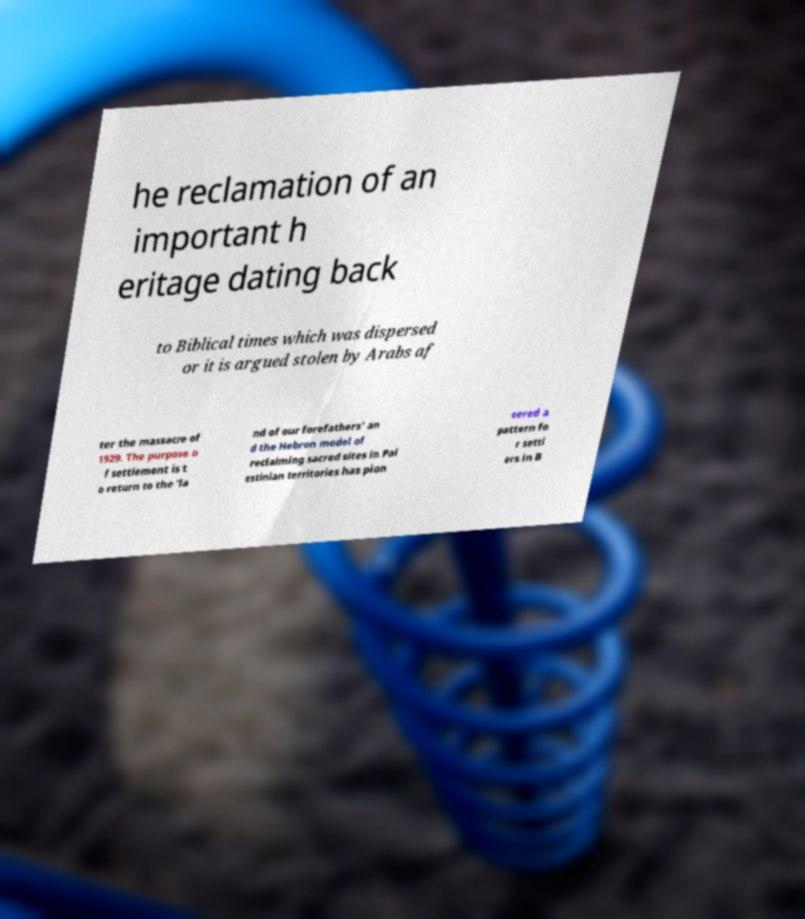Can you accurately transcribe the text from the provided image for me? he reclamation of an important h eritage dating back to Biblical times which was dispersed or it is argued stolen by Arabs af ter the massacre of 1929. The purpose o f settlement is t o return to the 'la nd of our forefathers' an d the Hebron model of reclaiming sacred sites in Pal estinian territories has pion eered a pattern fo r settl ers in B 